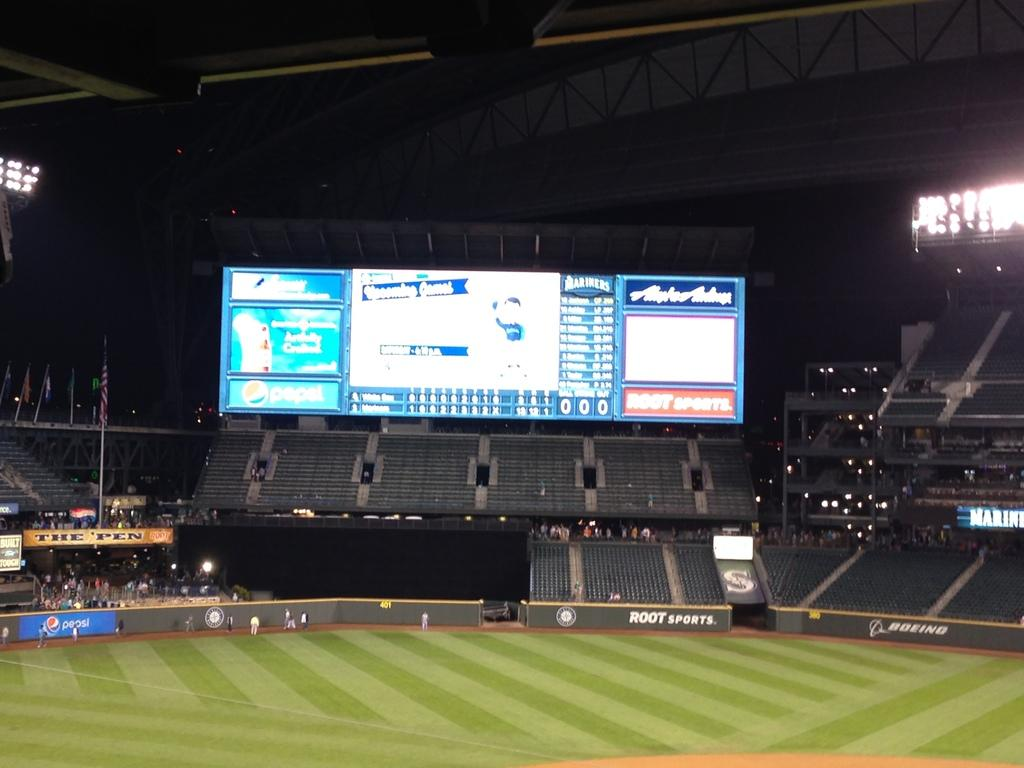<image>
Create a compact narrative representing the image presented. a baseball stadium with the company Boeing advertised on the outfield wall 